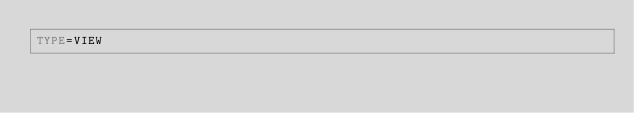Convert code to text. <code><loc_0><loc_0><loc_500><loc_500><_VisualBasic_>TYPE=VIEW</code> 